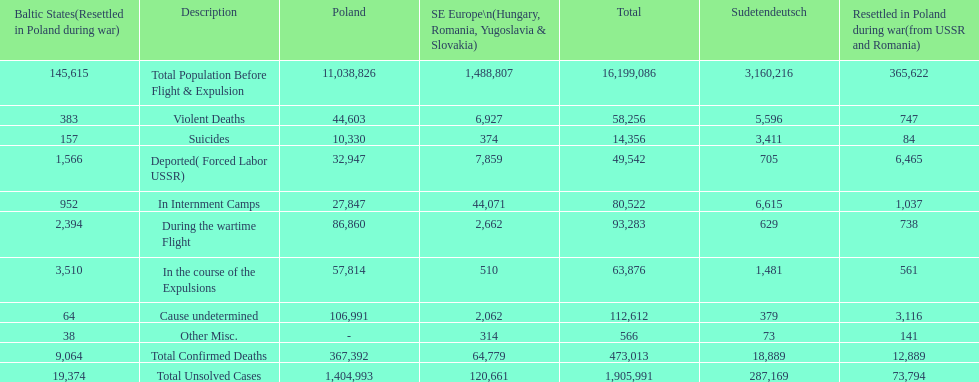Was there a larger total population before expulsion in poland or sudetendeutsch? Poland. 